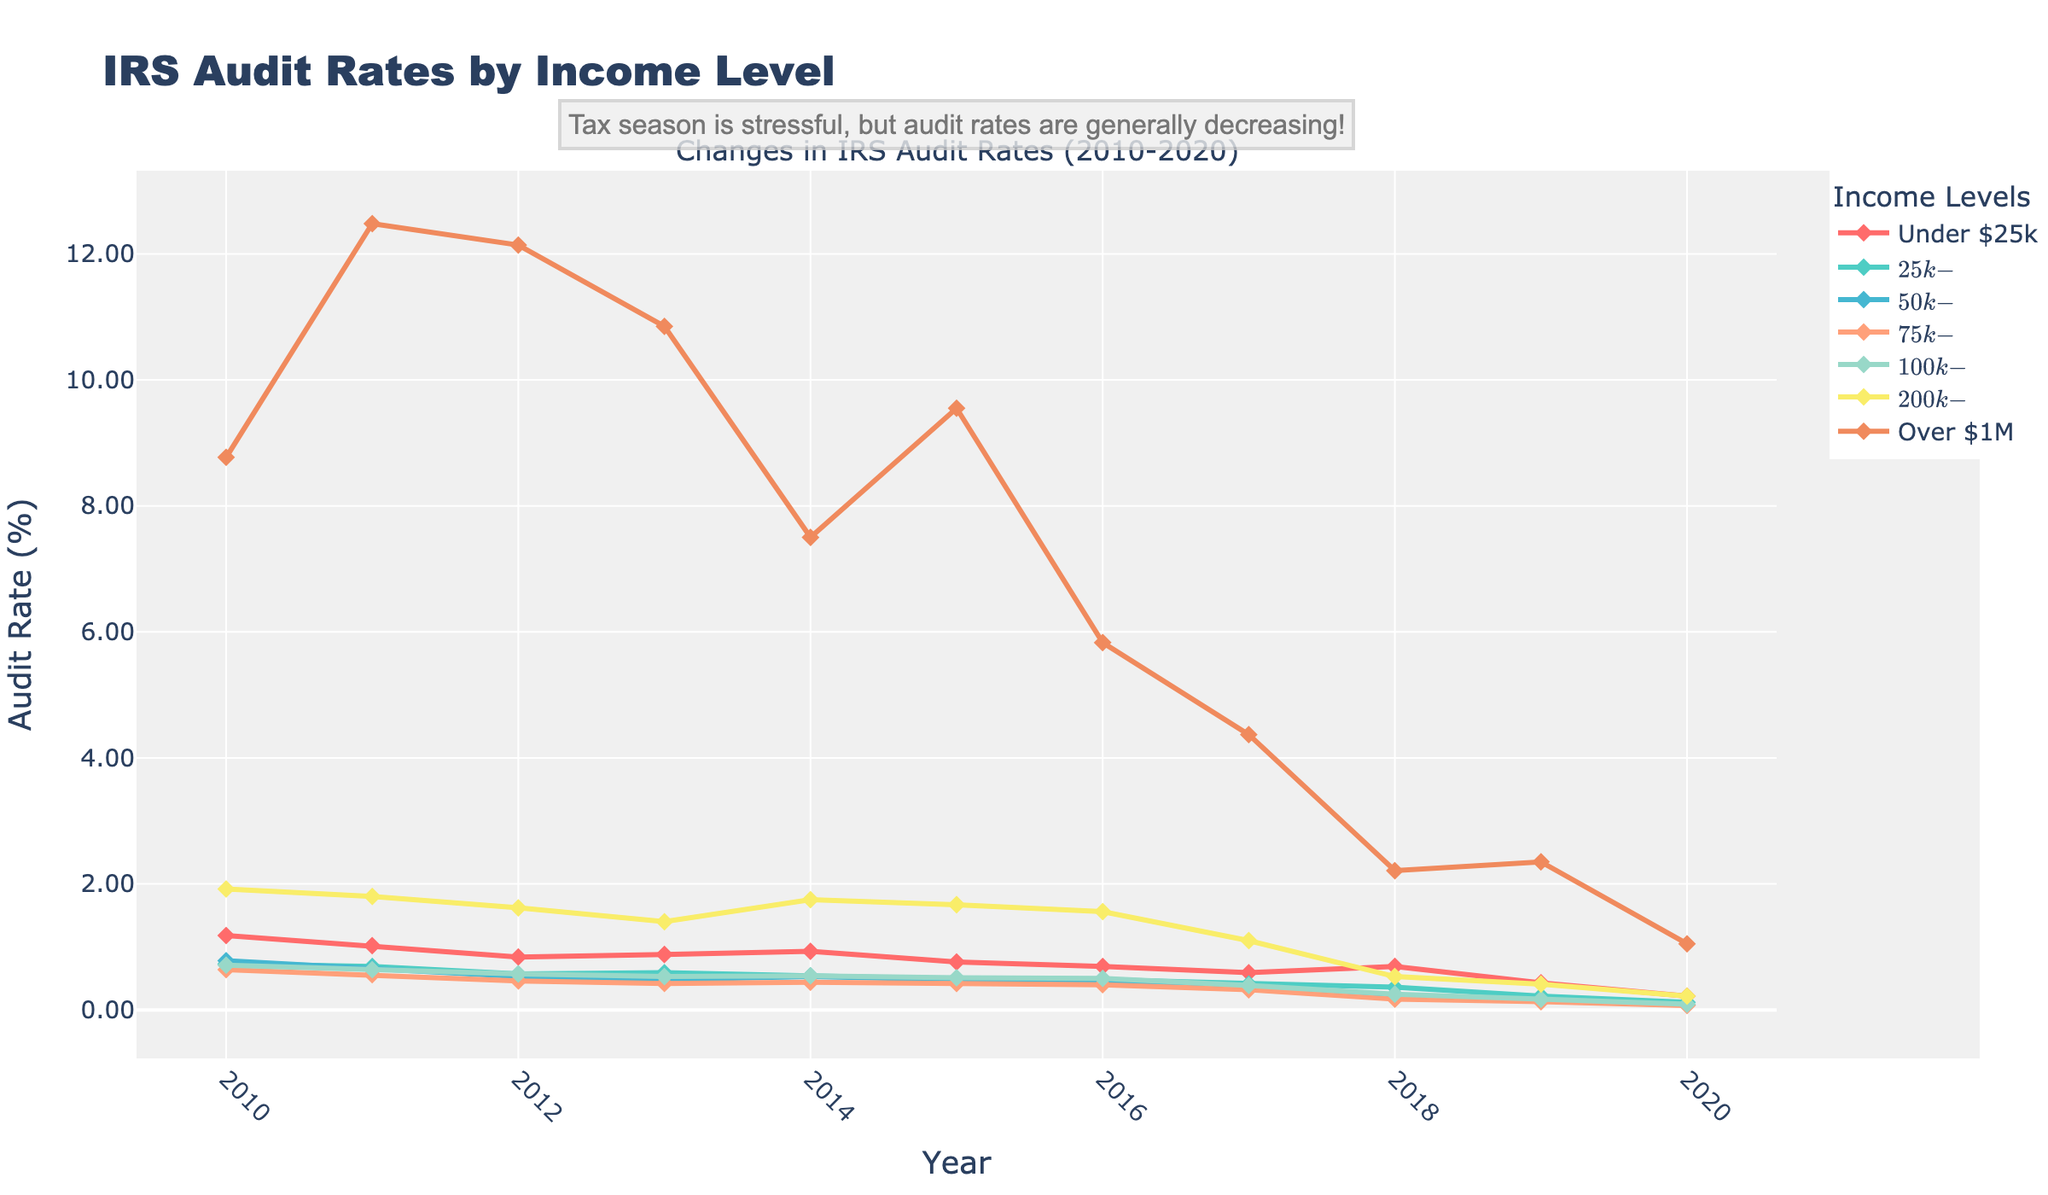What's the trend of audit rates for the "Under $25k" income level from 2010 to 2020? The audit rate for "Under $25k" shows a consistent decreasing trend from 2010 (~1.18%) to 2020 (~0.22%). Each year, the rate drops from the previous year, indicating a downward trend.
Answer: Decreasing trend Which income level experienced the greatest percentage drop in audit rates between 2010 and 2020? To find the greatest percentage drop, compare the 2010 and 2020 audit rates for each income level. The "Over $1M" income level drops from (~8.77%) in 2010 to (~1.05%) in 2020. The difference is 8.77%-1.05%=7.72%, which is the biggest decrease.
Answer: Over $1M In which year did the "$50k-$75k" income level have the lowest audit rate, and what was that rate? Review the plot for the "$50k-$75k" line to find the lowest point. The lowest audit rate occurs in 2020, at (~0.08%).
Answer: 2020, 0.08% Compare the audit rate trends of "Over $1M" and "$25k-$50k" from 2010 to 2020. Which had a sharper decline? Comparing the plot lines, "Over $1M" starts from (~8.77%) in 2010 and declines to (~1.05%) in 2020. "$25k-$50k" starts from (~0.73%) in 2010 to (~0.12%) in 2020. The decline for "Over $1M" is steeper since it drops more significantly.
Answer: Over $1M What is the average audit rate for the income level "$200k-$1M" over the given years? To calculate the average, sum the audit rates for "$200k-$1M" across the years and divide by the number of years. (1.92% + 1.80% + 1.62% + 1.40% + 1.75% + 1.67% + 1.56% + 1.10% + 0.53% + 0.41% + 0.22%)/11 ≈ 1.28%.
Answer: 1.28% Between which years did the "$75k-$100k" income level see the largest single-year drop in audit rates? Examine the year-over-year differences for "$75k-$100k". The largest single-year drop is from 2012 (~0.46%) to 2013 (~0.42%), a decrease of 0.04%.
Answer: 2012-2013 How do the audit rate trends for "Under $25k" from 2010 to 2020 compare to those for "Over $1M"? Both income levels experience a significant decrease. "Under $25k" falls from (~1.18%) to (~0.22%), while "Over $1M" falls from (~8.77%) to (~1.05%). Despite both decreasing, "Over $1M" shows a steeper decline overall.
Answer: Both decreasing, "Over $1M" steeper What year had the highest overall audit rates for all income levels combined, and why? To determine this, evaluate the plotted lines. 2010 had high rates overall: "Under $25k" (~1.18%), "$25k-$50k" (~0.73%), "$50k-$75k" (~0.78%), "$75k-$100k" (~0.64%), "$100k-$200k" (~0.71%), "$200k-$1M" (~1.92%), and "Over $1M" (~8.77%).
Answer: 2010 Identify the income level with the most noticeable change in audit rate trend between 2015 and 2020. Examine the lines for trends in 2015 to 2020. "Under $25k" shows a more apparent continuous drop from (~0.76%) in 2015 to (~0.22%) in 2020.
Answer: Under $25k 